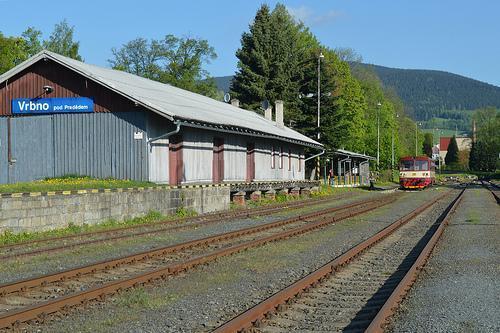How many trains in the train tracks?
Give a very brief answer. 1. 